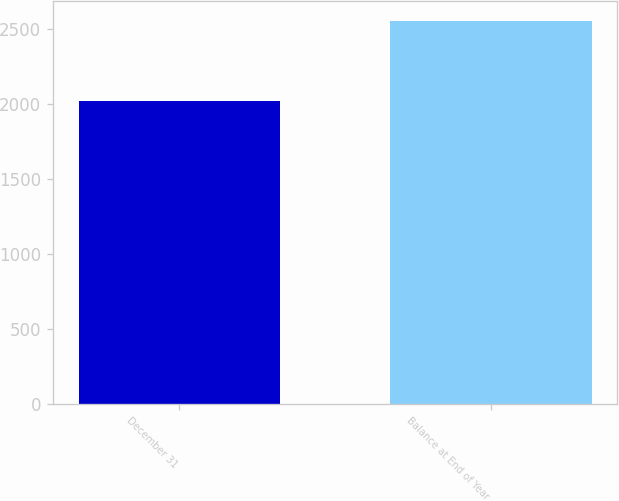<chart> <loc_0><loc_0><loc_500><loc_500><bar_chart><fcel>December 31<fcel>Balance at End of Year<nl><fcel>2015<fcel>2554<nl></chart> 